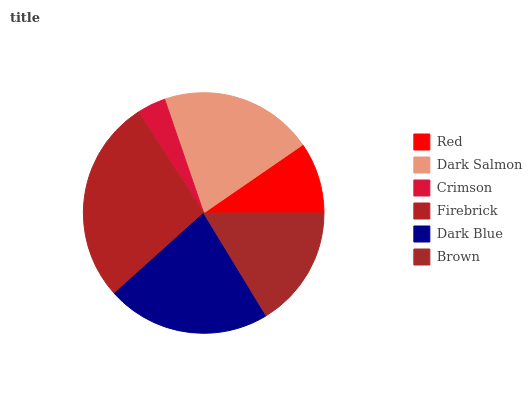Is Crimson the minimum?
Answer yes or no. Yes. Is Firebrick the maximum?
Answer yes or no. Yes. Is Dark Salmon the minimum?
Answer yes or no. No. Is Dark Salmon the maximum?
Answer yes or no. No. Is Dark Salmon greater than Red?
Answer yes or no. Yes. Is Red less than Dark Salmon?
Answer yes or no. Yes. Is Red greater than Dark Salmon?
Answer yes or no. No. Is Dark Salmon less than Red?
Answer yes or no. No. Is Dark Salmon the high median?
Answer yes or no. Yes. Is Brown the low median?
Answer yes or no. Yes. Is Brown the high median?
Answer yes or no. No. Is Dark Salmon the low median?
Answer yes or no. No. 